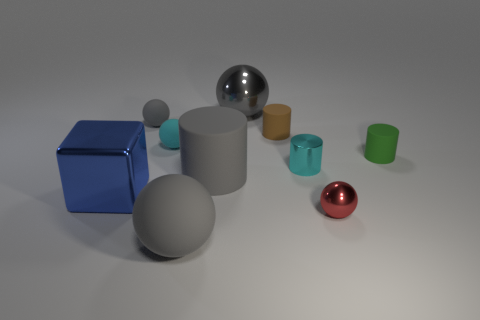Is there a big gray cylinder made of the same material as the red thing?
Provide a short and direct response. No. What shape is the metallic thing that is the same color as the big matte sphere?
Provide a succinct answer. Sphere. Is the number of big objects on the right side of the brown rubber thing less than the number of tiny brown rubber spheres?
Provide a succinct answer. No. Does the cylinder in front of the cyan cylinder have the same size as the large gray matte ball?
Provide a short and direct response. Yes. How many gray things are the same shape as the small red object?
Your response must be concise. 3. There is a brown thing that is the same material as the big gray cylinder; what is its size?
Your response must be concise. Small. Are there an equal number of cyan rubber spheres that are in front of the big rubber cylinder and large gray cubes?
Give a very brief answer. Yes. Does the big rubber cylinder have the same color as the big shiny ball?
Give a very brief answer. Yes. Does the rubber thing to the right of the tiny red thing have the same shape as the big gray thing behind the tiny brown rubber object?
Your response must be concise. No. What is the material of the tiny cyan object that is the same shape as the tiny green matte thing?
Your answer should be very brief. Metal. 